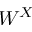<formula> <loc_0><loc_0><loc_500><loc_500>W ^ { X }</formula> 